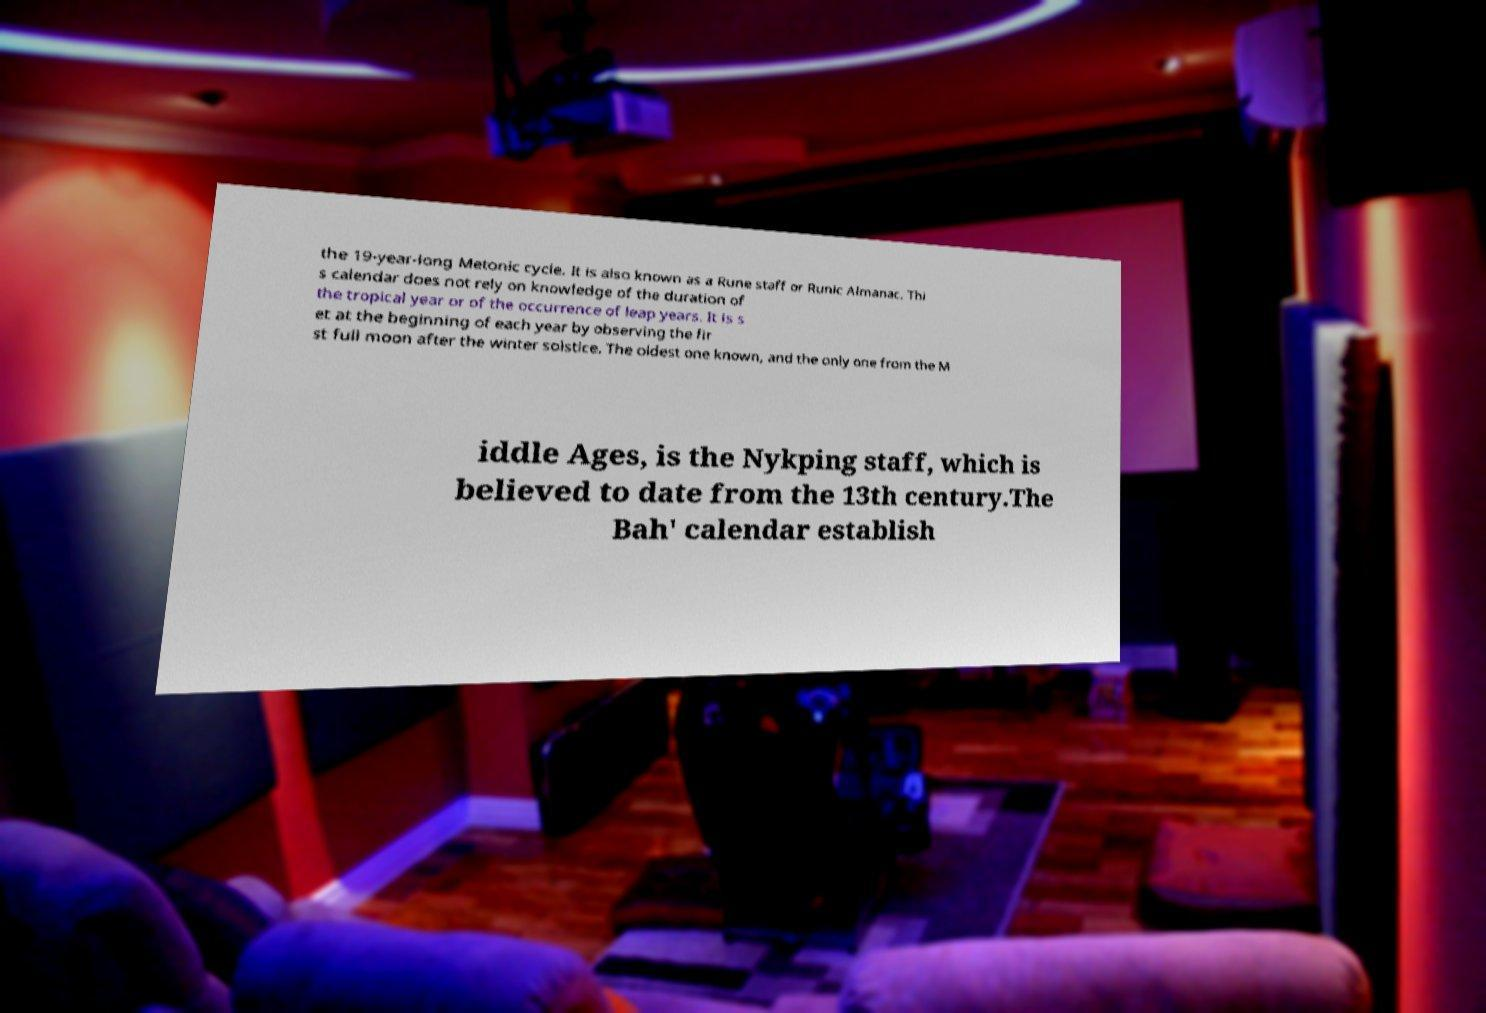Can you accurately transcribe the text from the provided image for me? the 19-year-long Metonic cycle. It is also known as a Rune staff or Runic Almanac. Thi s calendar does not rely on knowledge of the duration of the tropical year or of the occurrence of leap years. It is s et at the beginning of each year by observing the fir st full moon after the winter solstice. The oldest one known, and the only one from the M iddle Ages, is the Nykping staff, which is believed to date from the 13th century.The Bah' calendar establish 